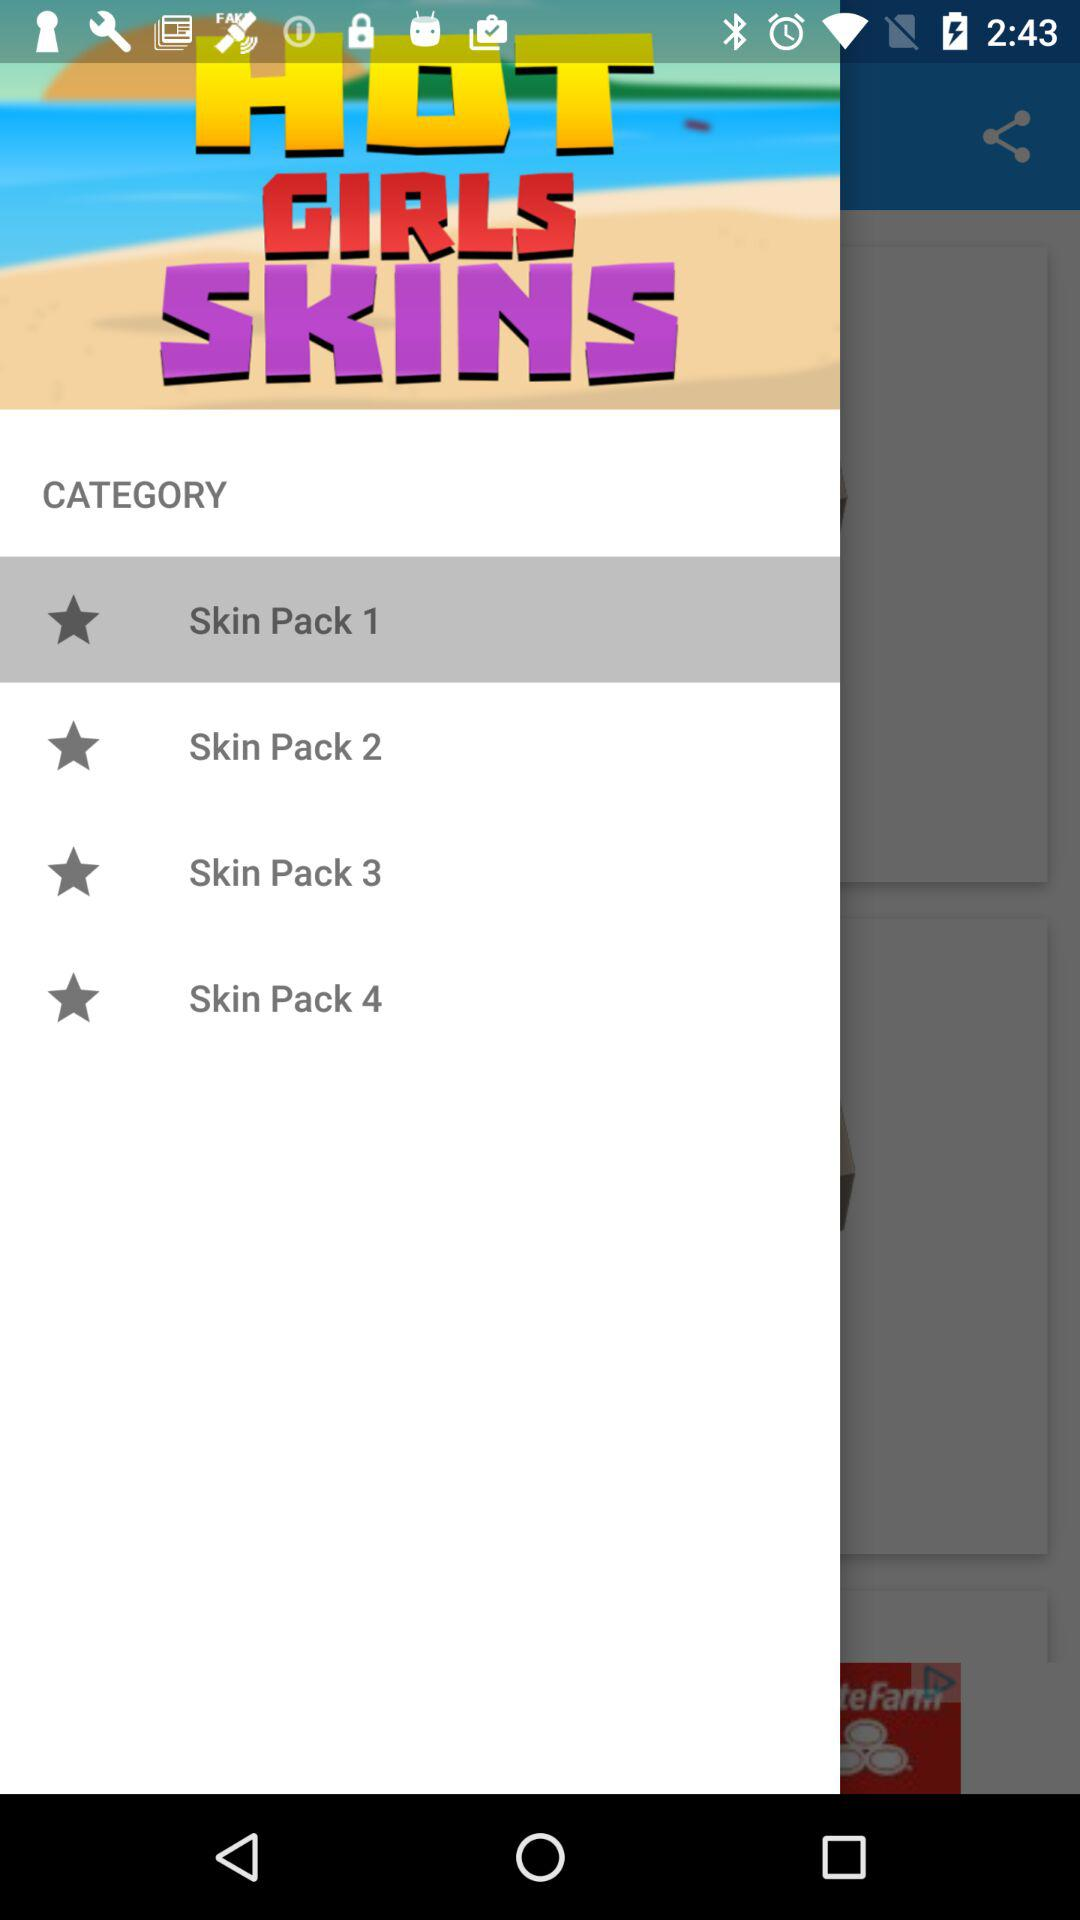Which item is selected? The selected item is "Skin Pack 1". 